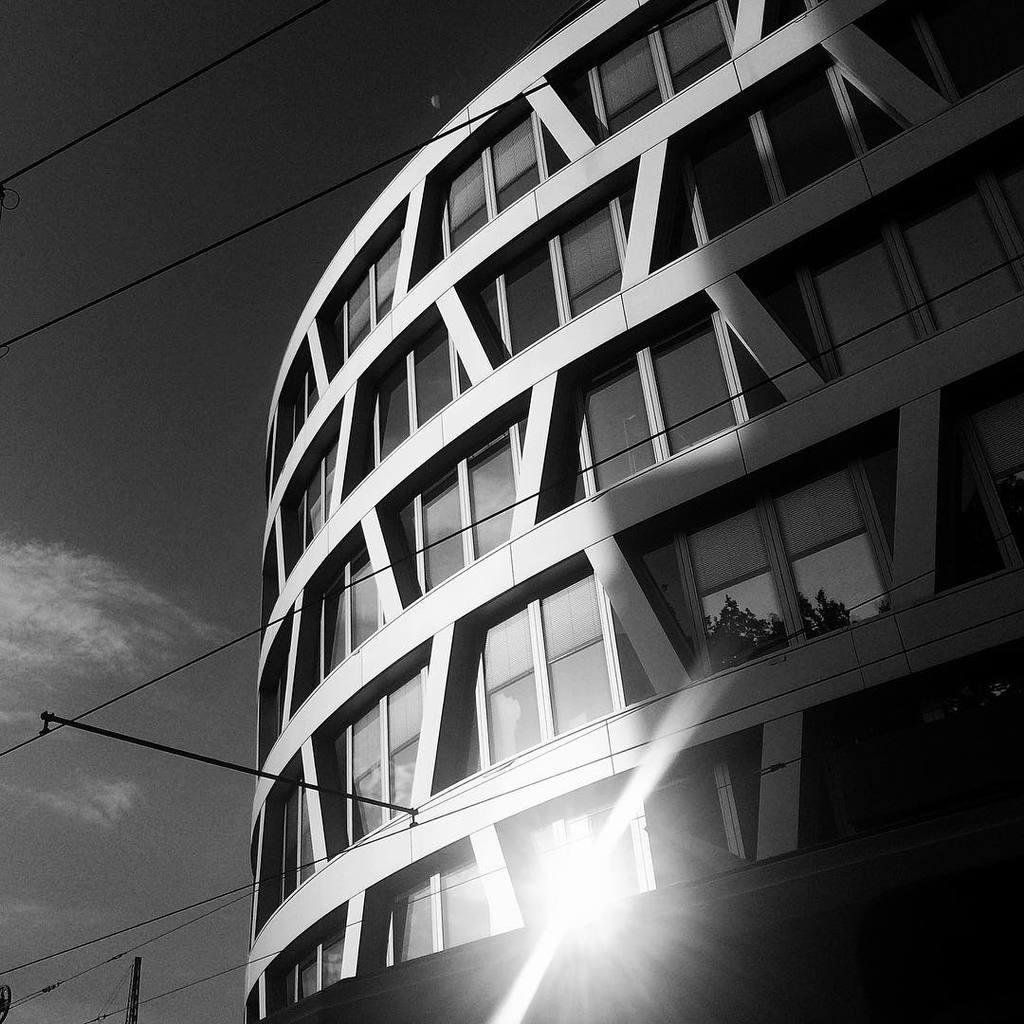Could you give a brief overview of what you see in this image? In this picture there is a building. On the left we can see sky and clouds. Here we can see electric wires are connected to this pipe. In the reflection we can see the tree and sun. 